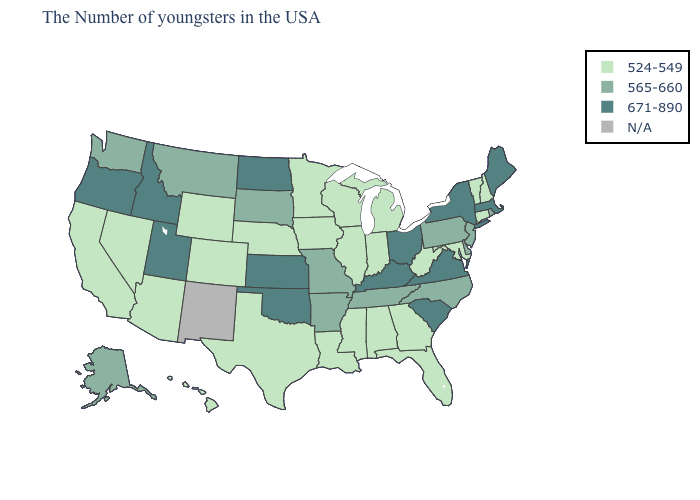What is the value of Iowa?
Write a very short answer. 524-549. Does the map have missing data?
Concise answer only. Yes. Which states have the lowest value in the USA?
Write a very short answer. New Hampshire, Vermont, Connecticut, Maryland, West Virginia, Florida, Georgia, Michigan, Indiana, Alabama, Wisconsin, Illinois, Mississippi, Louisiana, Minnesota, Iowa, Nebraska, Texas, Wyoming, Colorado, Arizona, Nevada, California, Hawaii. Which states have the lowest value in the USA?
Concise answer only. New Hampshire, Vermont, Connecticut, Maryland, West Virginia, Florida, Georgia, Michigan, Indiana, Alabama, Wisconsin, Illinois, Mississippi, Louisiana, Minnesota, Iowa, Nebraska, Texas, Wyoming, Colorado, Arizona, Nevada, California, Hawaii. What is the highest value in the USA?
Concise answer only. 671-890. Does Vermont have the lowest value in the USA?
Give a very brief answer. Yes. How many symbols are there in the legend?
Write a very short answer. 4. What is the highest value in the South ?
Be succinct. 671-890. What is the value of North Dakota?
Answer briefly. 671-890. What is the value of Wisconsin?
Quick response, please. 524-549. What is the value of Wisconsin?
Answer briefly. 524-549. Is the legend a continuous bar?
Write a very short answer. No. Name the states that have a value in the range 565-660?
Write a very short answer. Rhode Island, New Jersey, Delaware, Pennsylvania, North Carolina, Tennessee, Missouri, Arkansas, South Dakota, Montana, Washington, Alaska. What is the value of Alaska?
Answer briefly. 565-660. 